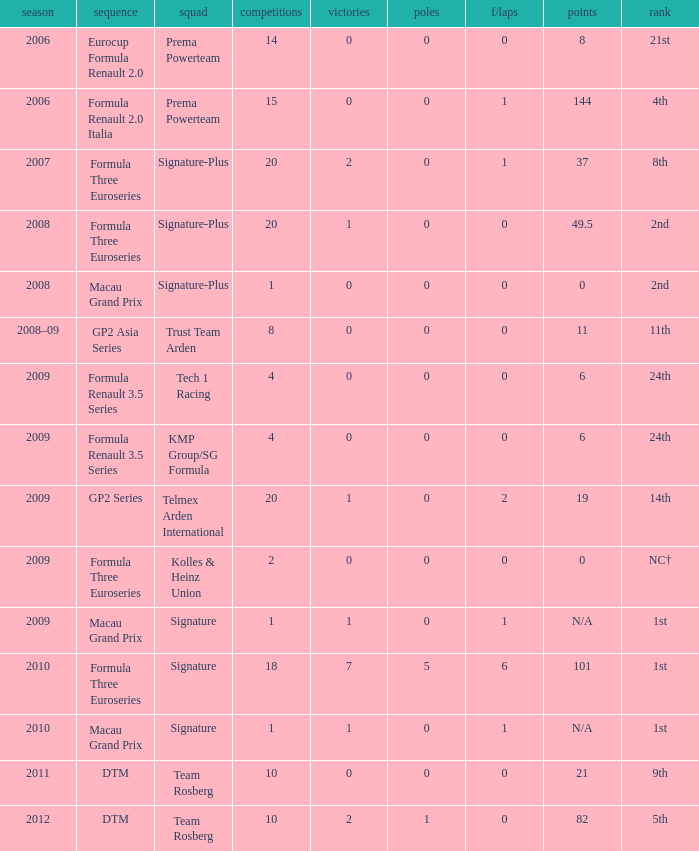How many races did the Formula Three Euroseries signature team have? 18.0. 